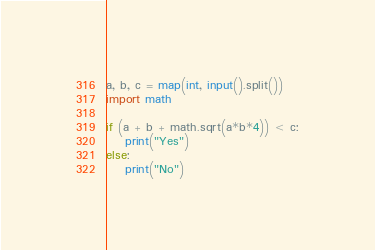<code> <loc_0><loc_0><loc_500><loc_500><_Python_>a, b, c = map(int, input().split())
import math

if (a + b + math.sqrt(a*b*4)) < c:
    print("Yes")
else:
    print("No")</code> 